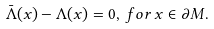<formula> <loc_0><loc_0><loc_500><loc_500>\bar { \Lambda } ( x ) - \Lambda ( x ) = 0 , \, f o r \, x \in \partial M .</formula> 